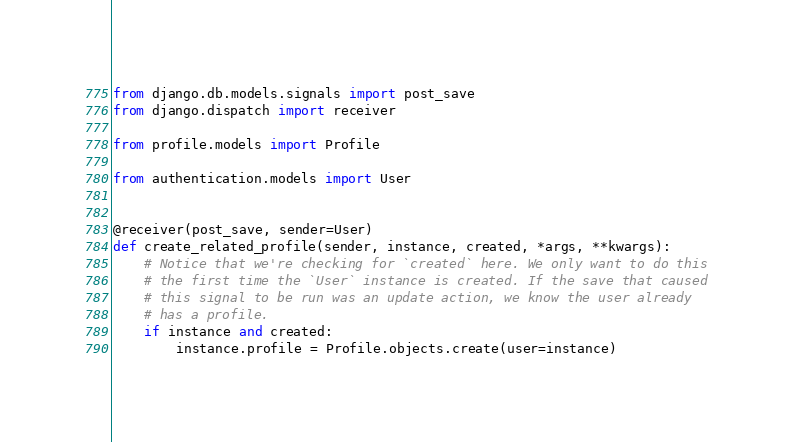Convert code to text. <code><loc_0><loc_0><loc_500><loc_500><_Python_>from django.db.models.signals import post_save
from django.dispatch import receiver

from profile.models import Profile

from authentication.models import User


@receiver(post_save, sender=User)
def create_related_profile(sender, instance, created, *args, **kwargs):
    # Notice that we're checking for `created` here. We only want to do this
    # the first time the `User` instance is created. If the save that caused
    # this signal to be run was an update action, we know the user already
    # has a profile.
    if instance and created:
        instance.profile = Profile.objects.create(user=instance)
</code> 